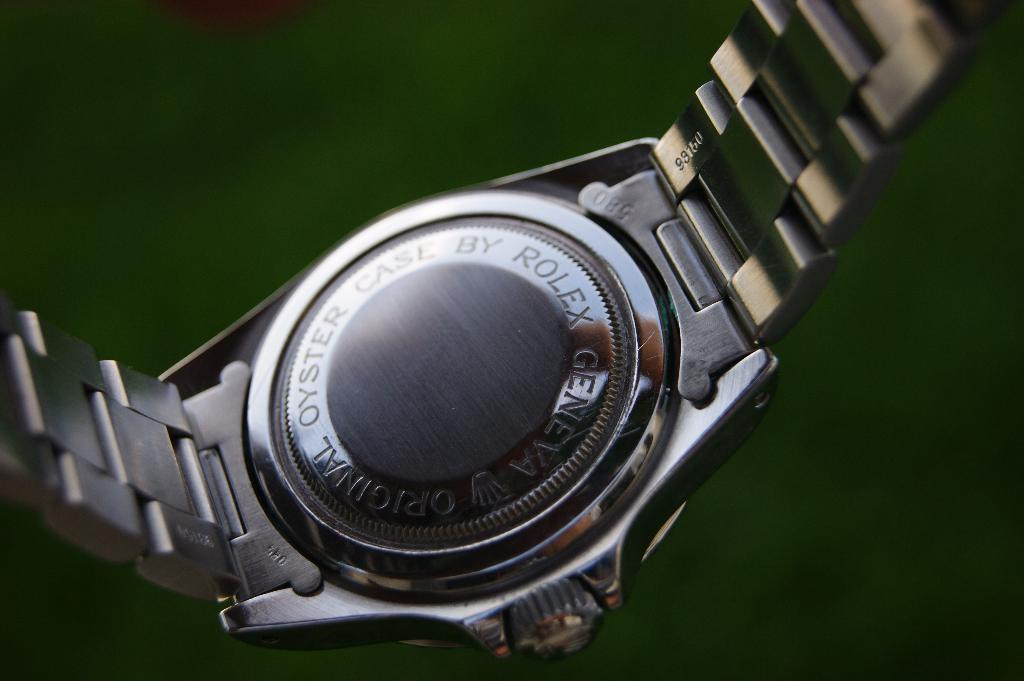<image>
Summarize the visual content of the image. The back of the Rolex watch is being shown above a green background. 